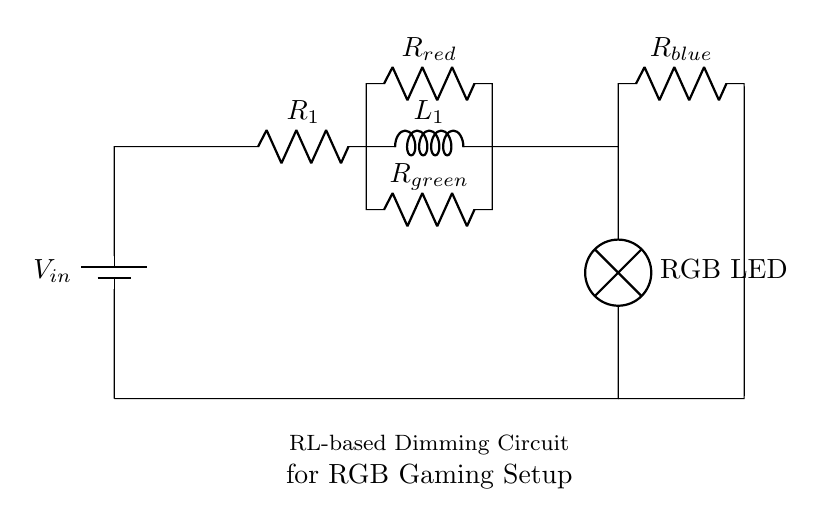What type of circuit is represented by this diagram? The circuit is an RL-based dimming circuit, which includes a resistor and an inductor used for controlling the brightness of RGB LEDs in a gaming setup.
Answer: RL-based dimming circuit What is the purpose of the inductor in this circuit? The inductor helps to smooth out current fluctuations, allowing for dimming of the RGB LEDs without sudden changes in brightness, thereby improving the quality of the light output.
Answer: Smoothing current How many resistors are in this circuit? The circuit contains three resistors, one for each color channel of the RGB LED: red, green, and blue.
Answer: Three Which component limits the current to the red LED? The component that limits the current to the red LED is the resistor labeled R_red, which is connected in series with the RGB LED segment for red.
Answer: R_red What is the voltage source in this circuit? The voltage source in the circuit is represented by the battery component at the top, which supplies the necessary power for the operation of the circuit.
Answer: V_in How does the circuit dim the RGB LEDs? The circuit dims the RGB LEDs by adjusting the resistance of the resistive components, impacting the current through the LEDs and effectively controlling their brightness.
Answer: By adjusting resistance What happens to the current when the inductor is energized? When the inductor is energized, it resists changes in current, causing the current to rise gradually rather than instantaneously, which allows for smoother control of brightness.
Answer: Gradual rise 